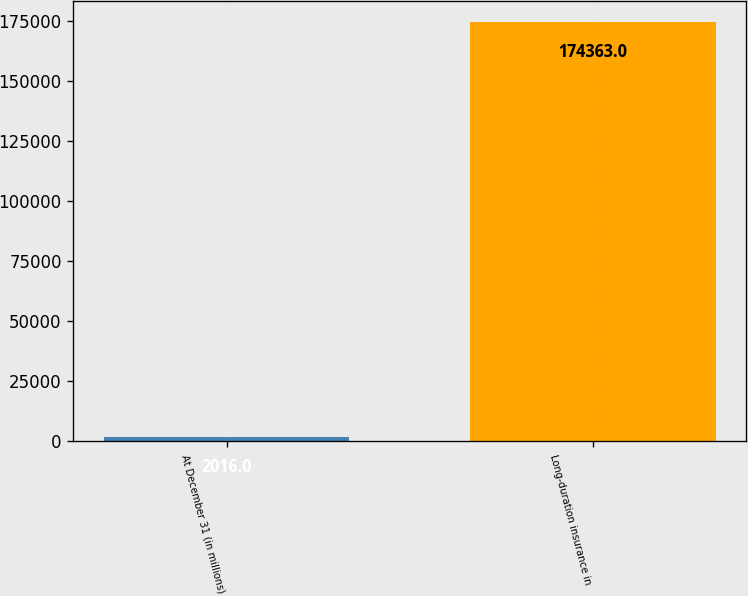Convert chart. <chart><loc_0><loc_0><loc_500><loc_500><bar_chart><fcel>At December 31 (in millions)<fcel>Long-duration insurance in<nl><fcel>2016<fcel>174363<nl></chart> 